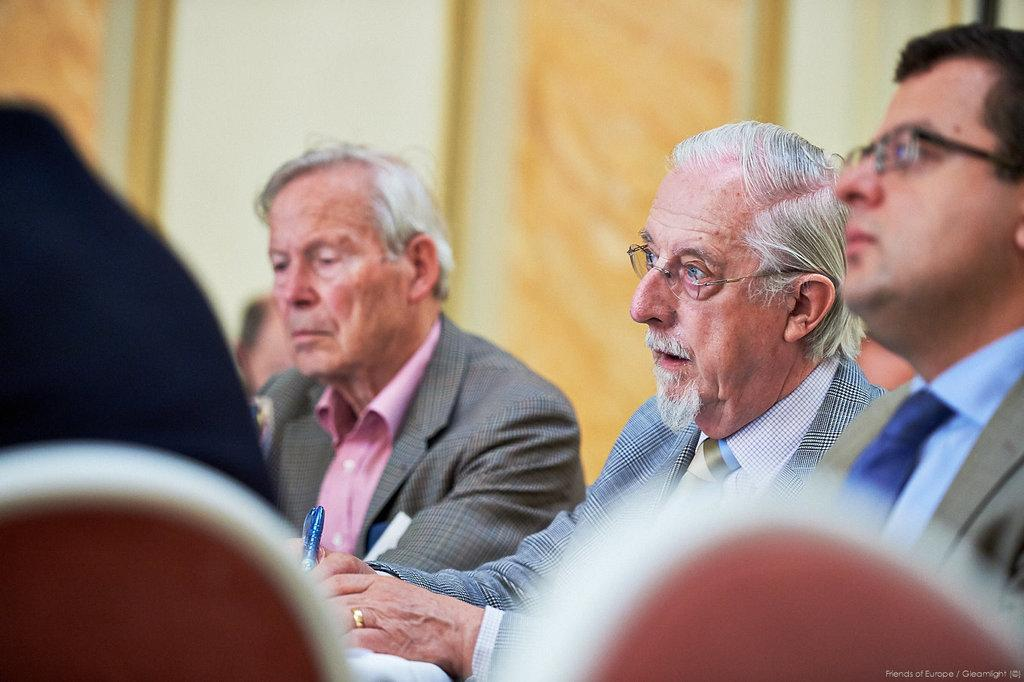How many men are in the image? There are three men in the image. What are the men wearing? The men are wearing suits. Can you describe the object being held by one of the men? One of the men is holding an object in his hand, but the specific object is not mentioned in the facts. What colors can be seen on the wall in the background of the image? The wall in the background of the image has white and orange colors. How does the memory of the men fall from the wall in the image? There is no mention of a memory or anything falling from the wall in the image. The wall has white and orange colors, but no falling objects are described. 